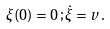Convert formula to latex. <formula><loc_0><loc_0><loc_500><loc_500>\xi ( 0 ) = 0 \, ; \dot { \xi } = v \, .</formula> 